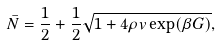<formula> <loc_0><loc_0><loc_500><loc_500>\bar { N } = \frac { 1 } { 2 } + \frac { 1 } { 2 } \sqrt { 1 + 4 \rho v \exp ( \beta G ) } , \\</formula> 